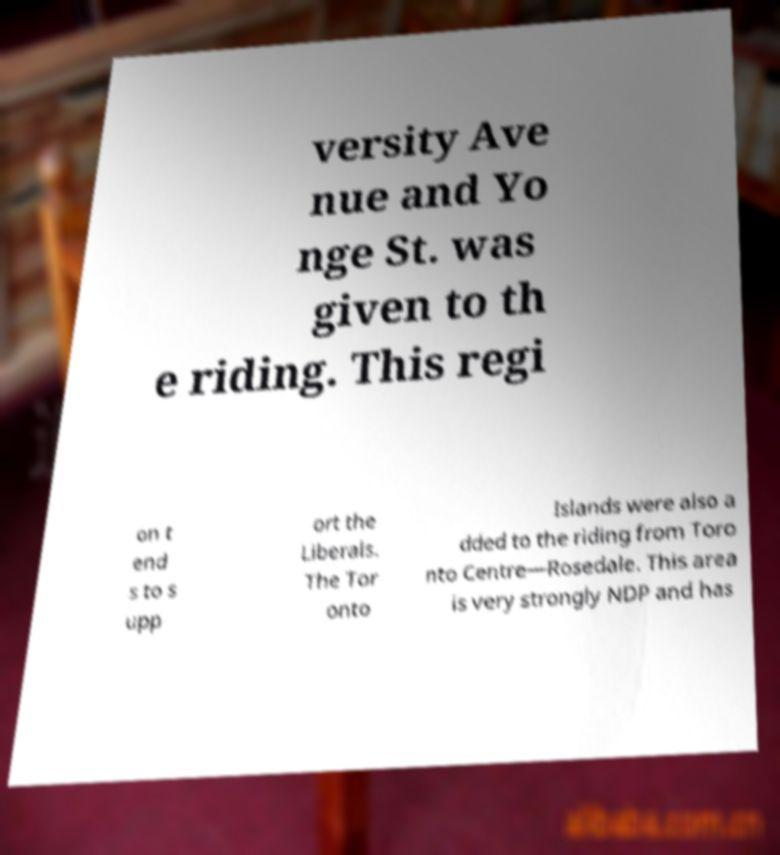Can you accurately transcribe the text from the provided image for me? versity Ave nue and Yo nge St. was given to th e riding. This regi on t end s to s upp ort the Liberals. The Tor onto Islands were also a dded to the riding from Toro nto Centre—Rosedale. This area is very strongly NDP and has 